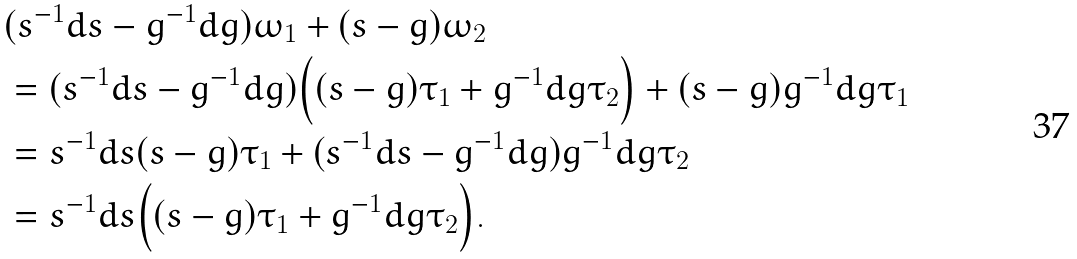<formula> <loc_0><loc_0><loc_500><loc_500>& ( s ^ { - 1 } d s - g ^ { - 1 } d g ) \omega _ { 1 } + ( s - g ) \omega _ { 2 } \\ & = ( s ^ { - 1 } d s - g ^ { - 1 } d g ) \Big { ( } ( s - g ) \tau _ { 1 } + g ^ { - 1 } d g \tau _ { 2 } \Big { ) } + ( s - g ) g ^ { - 1 } d g \tau _ { 1 } \\ & = s ^ { - 1 } d s ( s - g ) \tau _ { 1 } + { ( } s ^ { - 1 } d s - g ^ { - 1 } d g { ) } g ^ { - 1 } d g \tau _ { 2 } \\ & = s ^ { - 1 } d s \Big { ( } ( s - g ) \tau _ { 1 } + g ^ { - 1 } d g \tau _ { 2 } \Big { ) } .</formula> 